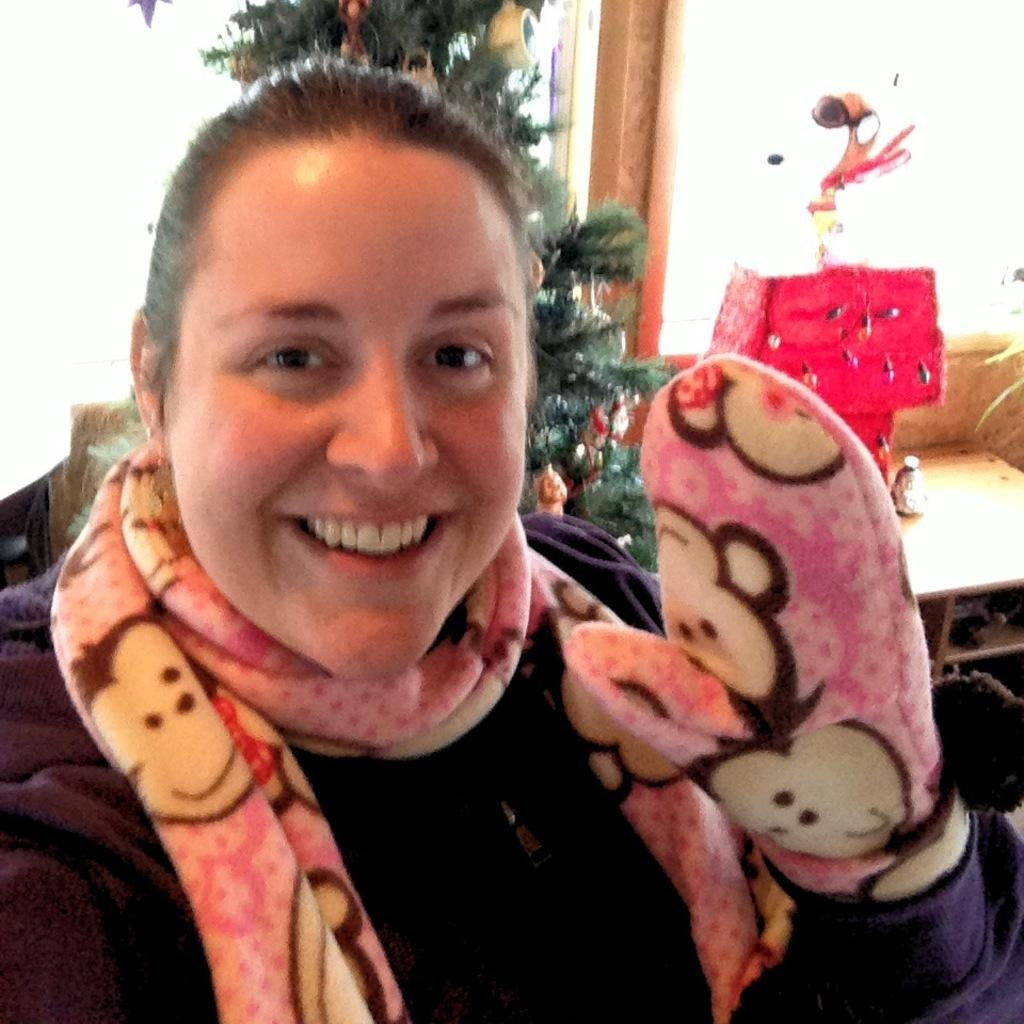Who is present in the image? There is a woman in the image. What is the woman wearing? The woman is wearing a black dress. What season might the image be associated with, given the presence of a Christmas tree? The image might be associated with the Christmas season. What type of furniture is visible in the image? There is a table in the image. What architectural feature is present in the image? There is a window in the image. What type of battle is depicted in the image? There is no battle depicted in the image; it features a woman, a Christmas tree, a table, and a window. What type of art can be seen on the wall in the image? There is no art visible on the wall in the image. 